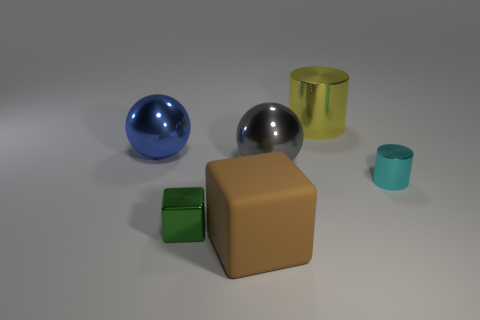What number of other things are the same shape as the matte thing?
Your answer should be very brief. 1. The big object that is both behind the small cylinder and in front of the large blue metallic thing has what shape?
Your answer should be very brief. Sphere. There is a large brown thing; are there any large brown things to the right of it?
Your answer should be very brief. No. The cyan metallic thing that is the same shape as the large yellow thing is what size?
Keep it short and to the point. Small. Is there any other thing that is the same size as the yellow shiny thing?
Provide a succinct answer. Yes. Is the shape of the gray thing the same as the yellow shiny object?
Your answer should be very brief. No. What size is the ball in front of the ball that is left of the rubber cube?
Provide a short and direct response. Large. The small metallic thing that is the same shape as the big brown thing is what color?
Your answer should be compact. Green. What number of other big matte things are the same color as the large rubber thing?
Your answer should be very brief. 0. The brown object has what size?
Offer a very short reply. Large. 